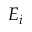<formula> <loc_0><loc_0><loc_500><loc_500>E _ { i }</formula> 